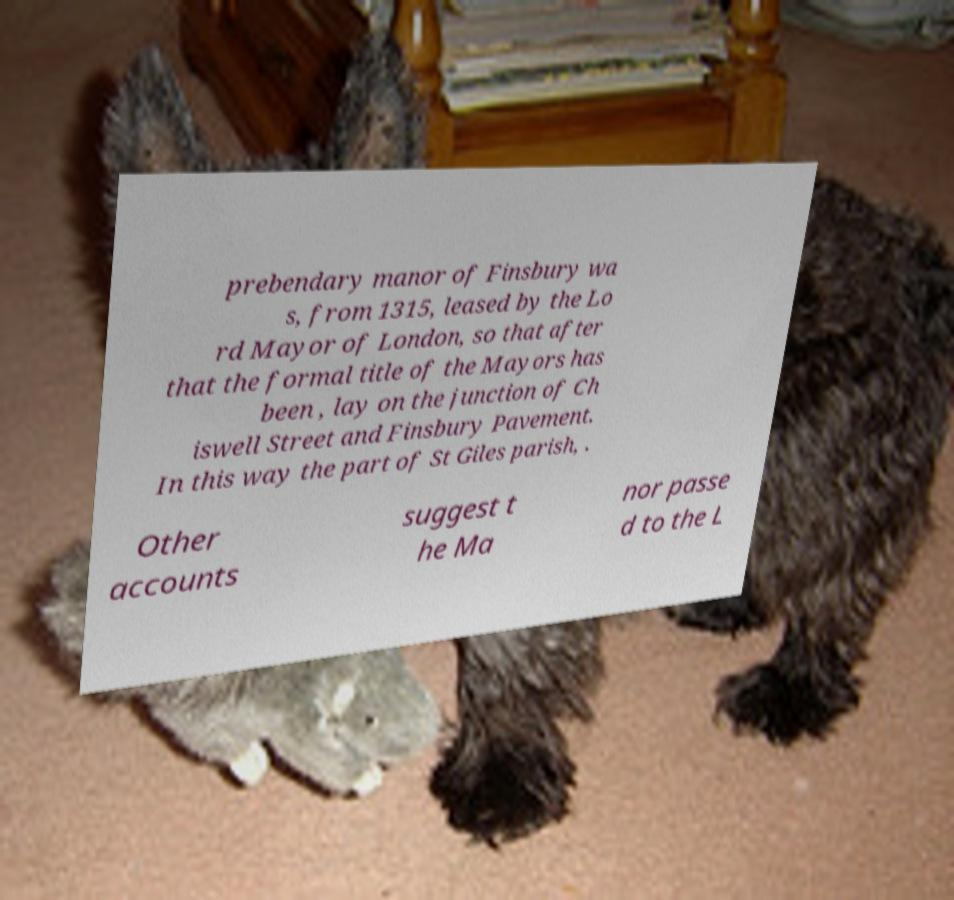Could you assist in decoding the text presented in this image and type it out clearly? prebendary manor of Finsbury wa s, from 1315, leased by the Lo rd Mayor of London, so that after that the formal title of the Mayors has been , lay on the junction of Ch iswell Street and Finsbury Pavement. In this way the part of St Giles parish, . Other accounts suggest t he Ma nor passe d to the L 